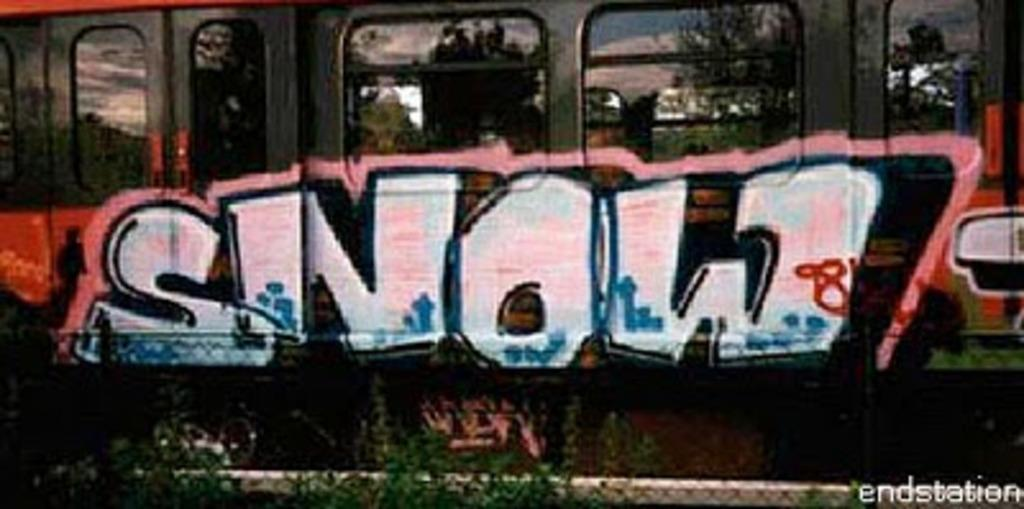<image>
Give a short and clear explanation of the subsequent image. Grafitti on a train that says SNOW in white. 